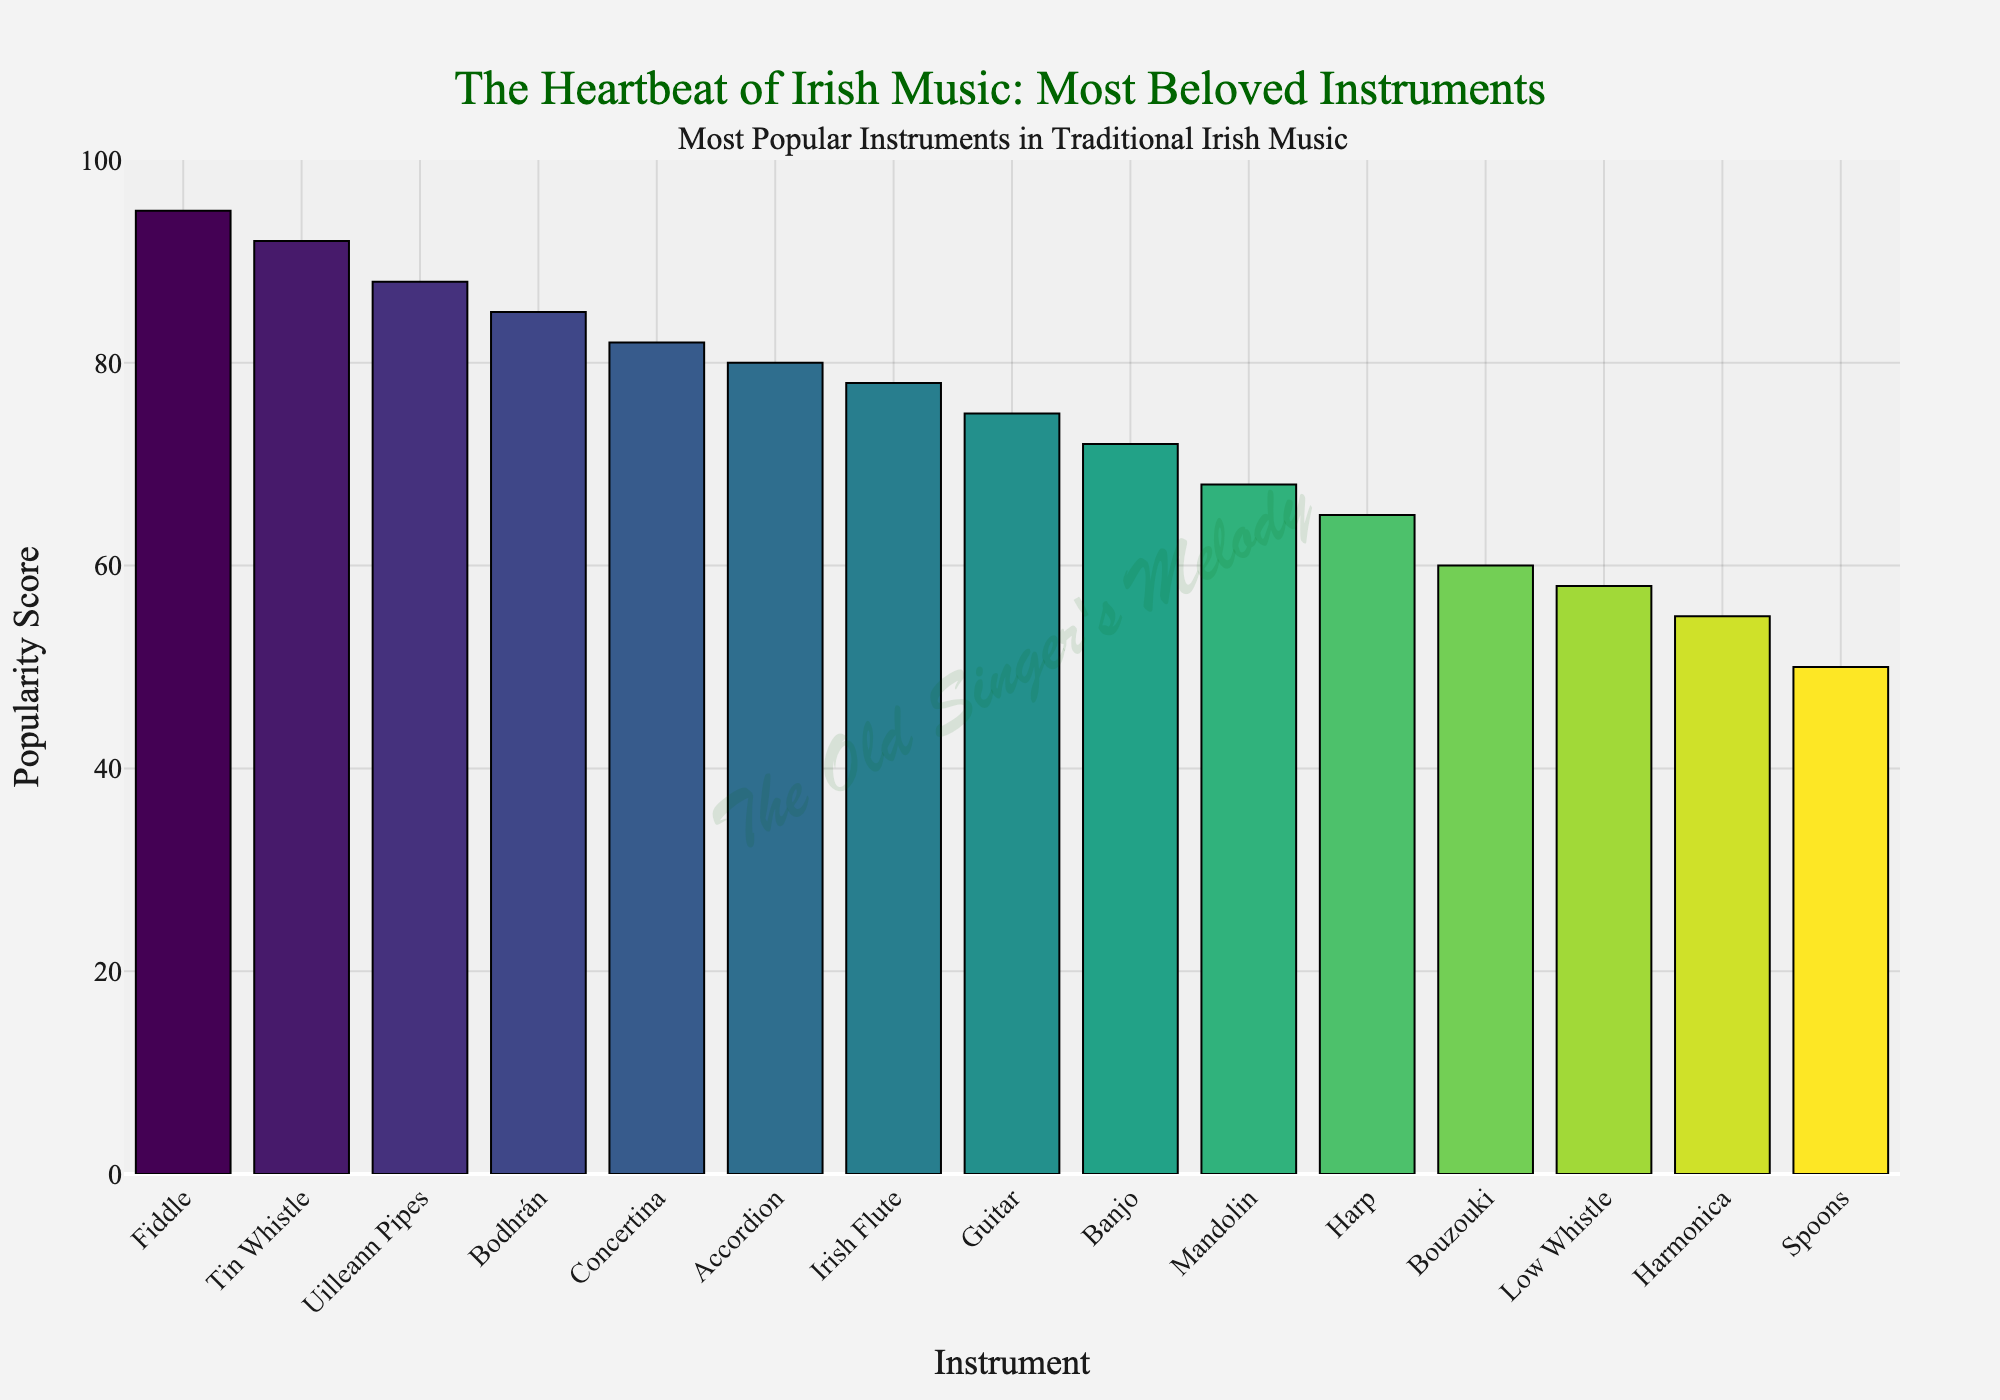Which instrument is the most popular according to the figure? The figure shows the popularity score for each instrument in traditional Irish music, listed in descending order. The first bar on the left has the highest score.
Answer: Fiddle Which instrument has a higher popularity score, the Guitar or the Banjo? By visually comparing the height of the bars representing these instruments, we can see that the Guitar's bar is slightly taller than the Banjo's.
Answer: Guitar What is the combined popularity score of the Tin Whistle and the Uilleann Pipes? The Tin Whistle has a popularity score of 92 and the Uilleann Pipes have a score of 88. Summing these scores: 92 + 88 = 180.
Answer: 180 How many instruments have a popularity score of 80 or higher? Visually counting the number of bars with a height corresponding to a score of 80 or above, we can see that there are 6 such instruments.
Answer: 6 What is the average popularity score of the Fiddle, Tin Whistle, and Uilleann Pipes? The scores are 95, 92, and 88 respectively. Adding them up: 95 + 92 + 88 = 275. Dividing by 3: 275 / 3 ≈ 91.67.
Answer: 91.67 Which instrument has a popularity score closest to 70? By examining the bars carefully, we find the Banjo with a score of 72 and the Mandolin with a score of 68. 72 is closer to 70.
Answer: Banjo Is the popularity score of the Bodhrán greater than or less than the popularity score of the Concertina? Comparing the bar heights, the Bodhrán, which has a score of 85, is taller than the Concertina, which has a score of 82.
Answer: Greater Which instrument is the least popular according to the figure? The last instrument on the right side of the chart, with the smallest bar, is the Spoons.
Answer: Spoons How does the popularity score of the Accordion compare to that of the Irish Flute? The Accordion has a popularity score of 80, while the Irish Flute has a score of 78. Therefore, the Accordion's popularity score is slightly higher.
Answer: Accordion 